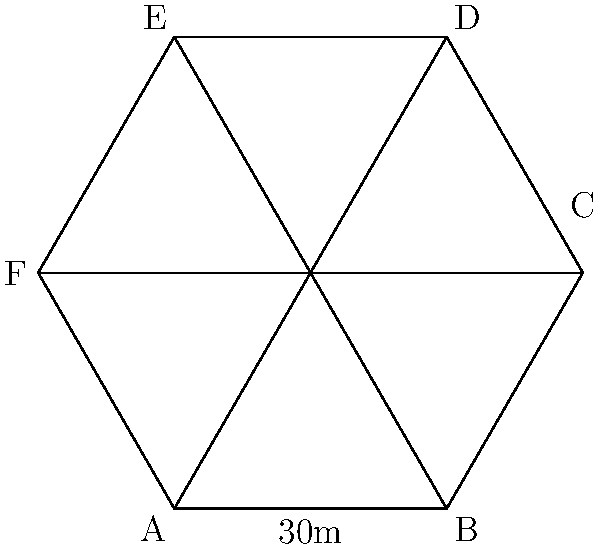A new hexagonal aircraft hangar is being designed to optimize space utilization for advanced propulsion system maintenance. The hangar has a regular hexagonal shape with a side length of 30 meters. What is the maximum floor area that can be utilized for maintenance activities if a 2-meter wide walkway is required along the entire perimeter of the hangar for safety and access purposes? Let's approach this step-by-step:

1) First, we need to calculate the total area of the hexagonal hangar:
   Area of a regular hexagon = $\frac{3\sqrt{3}}{2}s^2$, where $s$ is the side length
   Area = $\frac{3\sqrt{3}}{2} \cdot 30^2 = 2338.26$ m²

2) Now, we need to calculate the area of the walkway:
   a) The perimeter of the hexagon = $6s = 6 \cdot 30 = 180$ m
   b) Area of the walkway = Perimeter × Width = $180 \cdot 2 = 360$ m²

3) The maximum floor area for maintenance activities is the difference between the total area and the walkway area:
   Maintenance area = Total area - Walkway area
   Maintenance area = $2338.26 - 360 = 1978.26$ m²

Therefore, the maximum floor area that can be utilized for maintenance activities is approximately 1978.26 square meters.
Answer: 1978.26 m² 